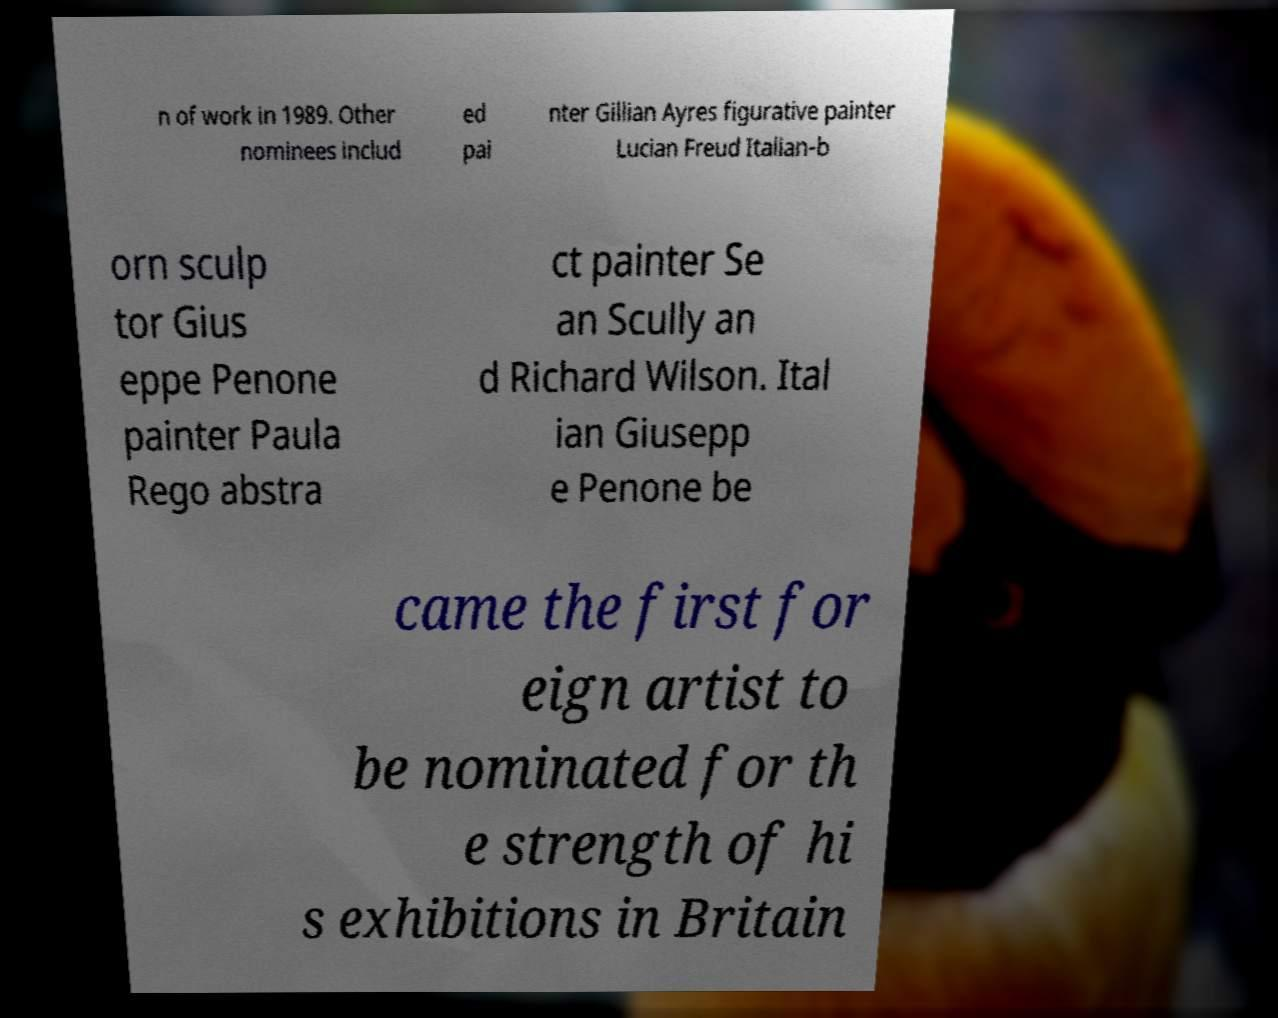Can you read and provide the text displayed in the image?This photo seems to have some interesting text. Can you extract and type it out for me? n of work in 1989. Other nominees includ ed pai nter Gillian Ayres figurative painter Lucian Freud Italian-b orn sculp tor Gius eppe Penone painter Paula Rego abstra ct painter Se an Scully an d Richard Wilson. Ital ian Giusepp e Penone be came the first for eign artist to be nominated for th e strength of hi s exhibitions in Britain 